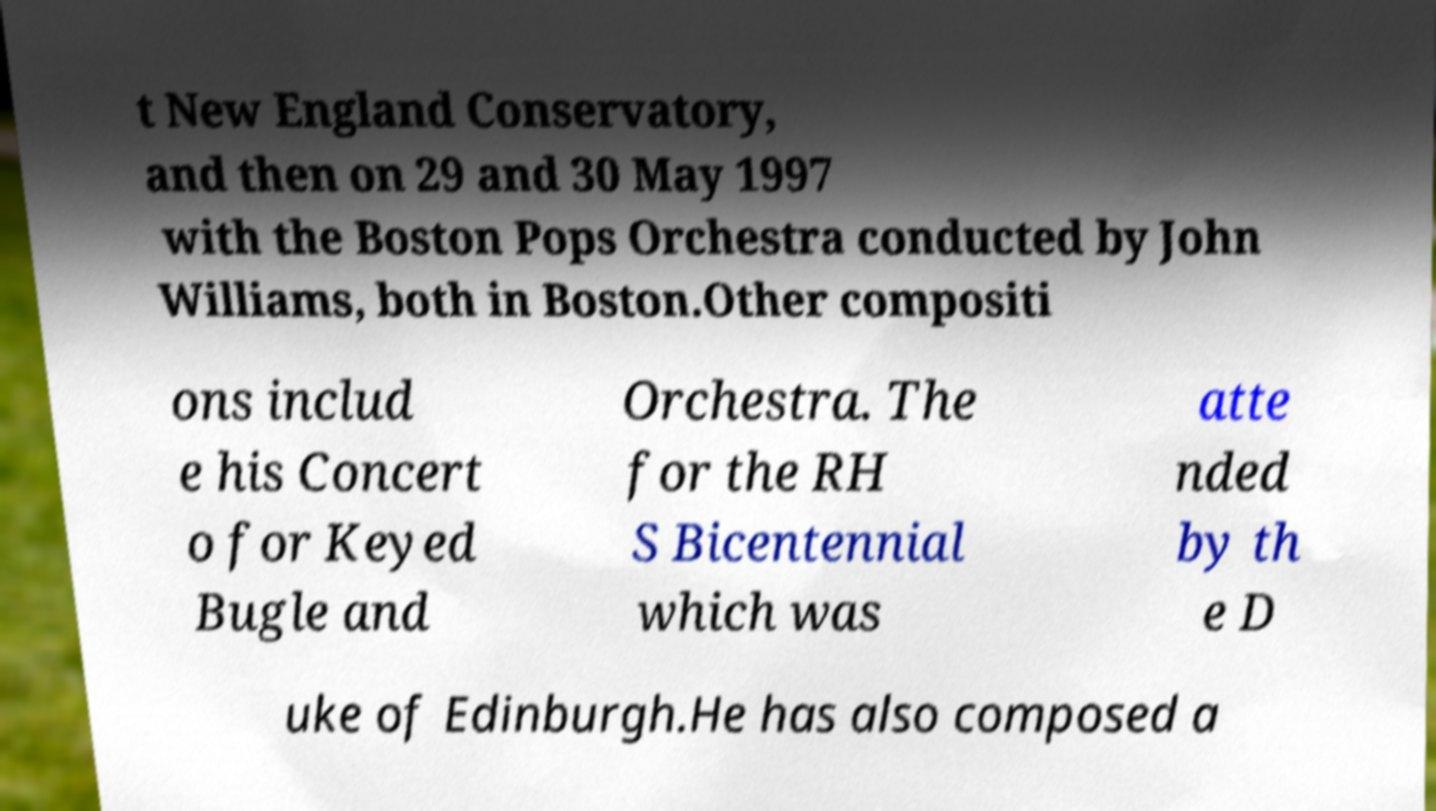Could you assist in decoding the text presented in this image and type it out clearly? t New England Conservatory, and then on 29 and 30 May 1997 with the Boston Pops Orchestra conducted by John Williams, both in Boston.Other compositi ons includ e his Concert o for Keyed Bugle and Orchestra. The for the RH S Bicentennial which was atte nded by th e D uke of Edinburgh.He has also composed a 